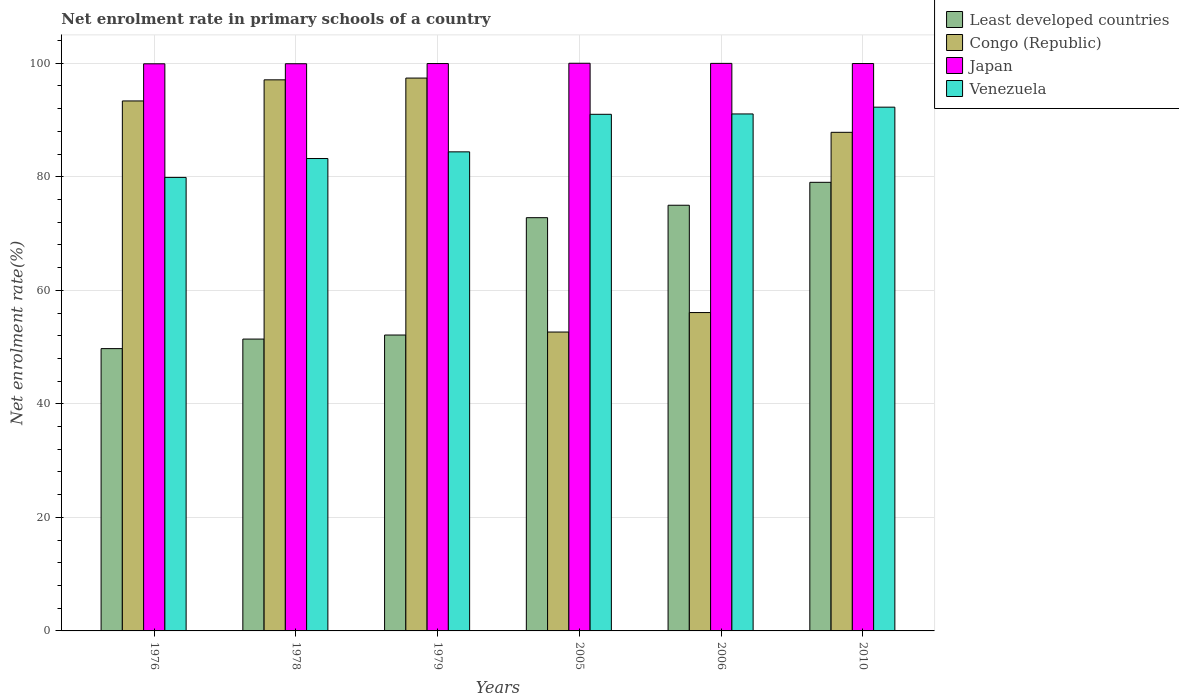How many groups of bars are there?
Provide a succinct answer. 6. Are the number of bars per tick equal to the number of legend labels?
Your response must be concise. Yes. In how many cases, is the number of bars for a given year not equal to the number of legend labels?
Provide a succinct answer. 0. What is the net enrolment rate in primary schools in Least developed countries in 2005?
Your response must be concise. 72.8. Across all years, what is the maximum net enrolment rate in primary schools in Venezuela?
Offer a terse response. 92.26. Across all years, what is the minimum net enrolment rate in primary schools in Congo (Republic)?
Offer a terse response. 52.65. In which year was the net enrolment rate in primary schools in Congo (Republic) maximum?
Your answer should be very brief. 1979. In which year was the net enrolment rate in primary schools in Least developed countries minimum?
Your answer should be compact. 1976. What is the total net enrolment rate in primary schools in Venezuela in the graph?
Your response must be concise. 521.84. What is the difference between the net enrolment rate in primary schools in Japan in 1976 and that in 1978?
Your answer should be compact. -0.01. What is the difference between the net enrolment rate in primary schools in Japan in 2010 and the net enrolment rate in primary schools in Venezuela in 1976?
Provide a succinct answer. 20.06. What is the average net enrolment rate in primary schools in Least developed countries per year?
Keep it short and to the point. 63.35. In the year 1978, what is the difference between the net enrolment rate in primary schools in Congo (Republic) and net enrolment rate in primary schools in Japan?
Make the answer very short. -2.83. What is the ratio of the net enrolment rate in primary schools in Least developed countries in 1978 to that in 2010?
Make the answer very short. 0.65. Is the net enrolment rate in primary schools in Congo (Republic) in 1978 less than that in 1979?
Give a very brief answer. Yes. What is the difference between the highest and the second highest net enrolment rate in primary schools in Japan?
Your answer should be very brief. 0.02. What is the difference between the highest and the lowest net enrolment rate in primary schools in Venezuela?
Keep it short and to the point. 12.37. Is the sum of the net enrolment rate in primary schools in Congo (Republic) in 1976 and 2005 greater than the maximum net enrolment rate in primary schools in Japan across all years?
Your response must be concise. Yes. Is it the case that in every year, the sum of the net enrolment rate in primary schools in Least developed countries and net enrolment rate in primary schools in Congo (Republic) is greater than the sum of net enrolment rate in primary schools in Japan and net enrolment rate in primary schools in Venezuela?
Give a very brief answer. No. What does the 3rd bar from the right in 2010 represents?
Your response must be concise. Congo (Republic). Are all the bars in the graph horizontal?
Provide a succinct answer. No. Are the values on the major ticks of Y-axis written in scientific E-notation?
Ensure brevity in your answer.  No. Where does the legend appear in the graph?
Your answer should be compact. Top right. How many legend labels are there?
Ensure brevity in your answer.  4. What is the title of the graph?
Keep it short and to the point. Net enrolment rate in primary schools of a country. Does "Central Europe" appear as one of the legend labels in the graph?
Provide a succinct answer. No. What is the label or title of the Y-axis?
Your answer should be very brief. Net enrolment rate(%). What is the Net enrolment rate(%) of Least developed countries in 1976?
Keep it short and to the point. 49.73. What is the Net enrolment rate(%) in Congo (Republic) in 1976?
Offer a very short reply. 93.36. What is the Net enrolment rate(%) of Japan in 1976?
Keep it short and to the point. 99.9. What is the Net enrolment rate(%) of Venezuela in 1976?
Ensure brevity in your answer.  79.89. What is the Net enrolment rate(%) of Least developed countries in 1978?
Ensure brevity in your answer.  51.41. What is the Net enrolment rate(%) of Congo (Republic) in 1978?
Provide a short and direct response. 97.08. What is the Net enrolment rate(%) of Japan in 1978?
Your response must be concise. 99.91. What is the Net enrolment rate(%) in Venezuela in 1978?
Provide a succinct answer. 83.22. What is the Net enrolment rate(%) in Least developed countries in 1979?
Your answer should be compact. 52.12. What is the Net enrolment rate(%) in Congo (Republic) in 1979?
Offer a very short reply. 97.39. What is the Net enrolment rate(%) of Japan in 1979?
Ensure brevity in your answer.  99.95. What is the Net enrolment rate(%) of Venezuela in 1979?
Provide a short and direct response. 84.39. What is the Net enrolment rate(%) in Least developed countries in 2005?
Keep it short and to the point. 72.8. What is the Net enrolment rate(%) in Congo (Republic) in 2005?
Ensure brevity in your answer.  52.65. What is the Net enrolment rate(%) of Japan in 2005?
Keep it short and to the point. 100. What is the Net enrolment rate(%) of Venezuela in 2005?
Provide a short and direct response. 91.01. What is the Net enrolment rate(%) in Least developed countries in 2006?
Keep it short and to the point. 74.99. What is the Net enrolment rate(%) of Congo (Republic) in 2006?
Provide a succinct answer. 56.08. What is the Net enrolment rate(%) in Japan in 2006?
Keep it short and to the point. 99.98. What is the Net enrolment rate(%) in Venezuela in 2006?
Make the answer very short. 91.07. What is the Net enrolment rate(%) in Least developed countries in 2010?
Give a very brief answer. 79.03. What is the Net enrolment rate(%) of Congo (Republic) in 2010?
Provide a short and direct response. 87.83. What is the Net enrolment rate(%) of Japan in 2010?
Keep it short and to the point. 99.95. What is the Net enrolment rate(%) in Venezuela in 2010?
Give a very brief answer. 92.26. Across all years, what is the maximum Net enrolment rate(%) in Least developed countries?
Ensure brevity in your answer.  79.03. Across all years, what is the maximum Net enrolment rate(%) in Congo (Republic)?
Give a very brief answer. 97.39. Across all years, what is the maximum Net enrolment rate(%) in Japan?
Provide a succinct answer. 100. Across all years, what is the maximum Net enrolment rate(%) in Venezuela?
Provide a short and direct response. 92.26. Across all years, what is the minimum Net enrolment rate(%) of Least developed countries?
Your answer should be very brief. 49.73. Across all years, what is the minimum Net enrolment rate(%) of Congo (Republic)?
Offer a terse response. 52.65. Across all years, what is the minimum Net enrolment rate(%) in Japan?
Provide a short and direct response. 99.9. Across all years, what is the minimum Net enrolment rate(%) of Venezuela?
Ensure brevity in your answer.  79.89. What is the total Net enrolment rate(%) of Least developed countries in the graph?
Provide a succinct answer. 380.07. What is the total Net enrolment rate(%) of Congo (Republic) in the graph?
Keep it short and to the point. 484.4. What is the total Net enrolment rate(%) in Japan in the graph?
Offer a terse response. 599.69. What is the total Net enrolment rate(%) in Venezuela in the graph?
Offer a very short reply. 521.84. What is the difference between the Net enrolment rate(%) of Least developed countries in 1976 and that in 1978?
Your answer should be compact. -1.68. What is the difference between the Net enrolment rate(%) in Congo (Republic) in 1976 and that in 1978?
Your answer should be compact. -3.72. What is the difference between the Net enrolment rate(%) in Japan in 1976 and that in 1978?
Your answer should be very brief. -0.01. What is the difference between the Net enrolment rate(%) in Venezuela in 1976 and that in 1978?
Ensure brevity in your answer.  -3.33. What is the difference between the Net enrolment rate(%) in Least developed countries in 1976 and that in 1979?
Give a very brief answer. -2.39. What is the difference between the Net enrolment rate(%) in Congo (Republic) in 1976 and that in 1979?
Keep it short and to the point. -4.03. What is the difference between the Net enrolment rate(%) of Japan in 1976 and that in 1979?
Keep it short and to the point. -0.04. What is the difference between the Net enrolment rate(%) in Venezuela in 1976 and that in 1979?
Make the answer very short. -4.5. What is the difference between the Net enrolment rate(%) of Least developed countries in 1976 and that in 2005?
Your response must be concise. -23.07. What is the difference between the Net enrolment rate(%) in Congo (Republic) in 1976 and that in 2005?
Your answer should be very brief. 40.71. What is the difference between the Net enrolment rate(%) in Japan in 1976 and that in 2005?
Your answer should be very brief. -0.09. What is the difference between the Net enrolment rate(%) of Venezuela in 1976 and that in 2005?
Your answer should be very brief. -11.12. What is the difference between the Net enrolment rate(%) in Least developed countries in 1976 and that in 2006?
Give a very brief answer. -25.26. What is the difference between the Net enrolment rate(%) in Congo (Republic) in 1976 and that in 2006?
Give a very brief answer. 37.28. What is the difference between the Net enrolment rate(%) of Japan in 1976 and that in 2006?
Provide a succinct answer. -0.07. What is the difference between the Net enrolment rate(%) in Venezuela in 1976 and that in 2006?
Ensure brevity in your answer.  -11.18. What is the difference between the Net enrolment rate(%) in Least developed countries in 1976 and that in 2010?
Provide a succinct answer. -29.3. What is the difference between the Net enrolment rate(%) in Congo (Republic) in 1976 and that in 2010?
Your answer should be very brief. 5.53. What is the difference between the Net enrolment rate(%) in Japan in 1976 and that in 2010?
Offer a terse response. -0.05. What is the difference between the Net enrolment rate(%) in Venezuela in 1976 and that in 2010?
Keep it short and to the point. -12.37. What is the difference between the Net enrolment rate(%) of Least developed countries in 1978 and that in 1979?
Provide a short and direct response. -0.71. What is the difference between the Net enrolment rate(%) of Congo (Republic) in 1978 and that in 1979?
Keep it short and to the point. -0.31. What is the difference between the Net enrolment rate(%) in Japan in 1978 and that in 1979?
Keep it short and to the point. -0.03. What is the difference between the Net enrolment rate(%) in Venezuela in 1978 and that in 1979?
Ensure brevity in your answer.  -1.18. What is the difference between the Net enrolment rate(%) in Least developed countries in 1978 and that in 2005?
Offer a terse response. -21.39. What is the difference between the Net enrolment rate(%) of Congo (Republic) in 1978 and that in 2005?
Provide a short and direct response. 44.43. What is the difference between the Net enrolment rate(%) of Japan in 1978 and that in 2005?
Keep it short and to the point. -0.09. What is the difference between the Net enrolment rate(%) of Venezuela in 1978 and that in 2005?
Give a very brief answer. -7.79. What is the difference between the Net enrolment rate(%) of Least developed countries in 1978 and that in 2006?
Make the answer very short. -23.58. What is the difference between the Net enrolment rate(%) of Congo (Republic) in 1978 and that in 2006?
Your answer should be compact. 40.99. What is the difference between the Net enrolment rate(%) in Japan in 1978 and that in 2006?
Your response must be concise. -0.06. What is the difference between the Net enrolment rate(%) of Venezuela in 1978 and that in 2006?
Your answer should be compact. -7.85. What is the difference between the Net enrolment rate(%) in Least developed countries in 1978 and that in 2010?
Make the answer very short. -27.61. What is the difference between the Net enrolment rate(%) in Congo (Republic) in 1978 and that in 2010?
Your response must be concise. 9.25. What is the difference between the Net enrolment rate(%) of Japan in 1978 and that in 2010?
Keep it short and to the point. -0.04. What is the difference between the Net enrolment rate(%) of Venezuela in 1978 and that in 2010?
Your answer should be very brief. -9.05. What is the difference between the Net enrolment rate(%) of Least developed countries in 1979 and that in 2005?
Ensure brevity in your answer.  -20.67. What is the difference between the Net enrolment rate(%) in Congo (Republic) in 1979 and that in 2005?
Offer a very short reply. 44.74. What is the difference between the Net enrolment rate(%) in Japan in 1979 and that in 2005?
Your response must be concise. -0.05. What is the difference between the Net enrolment rate(%) of Venezuela in 1979 and that in 2005?
Your answer should be very brief. -6.61. What is the difference between the Net enrolment rate(%) of Least developed countries in 1979 and that in 2006?
Your answer should be compact. -22.86. What is the difference between the Net enrolment rate(%) of Congo (Republic) in 1979 and that in 2006?
Ensure brevity in your answer.  41.31. What is the difference between the Net enrolment rate(%) in Japan in 1979 and that in 2006?
Provide a succinct answer. -0.03. What is the difference between the Net enrolment rate(%) in Venezuela in 1979 and that in 2006?
Ensure brevity in your answer.  -6.68. What is the difference between the Net enrolment rate(%) of Least developed countries in 1979 and that in 2010?
Your response must be concise. -26.9. What is the difference between the Net enrolment rate(%) in Congo (Republic) in 1979 and that in 2010?
Provide a succinct answer. 9.56. What is the difference between the Net enrolment rate(%) in Japan in 1979 and that in 2010?
Provide a short and direct response. -0. What is the difference between the Net enrolment rate(%) in Venezuela in 1979 and that in 2010?
Your answer should be very brief. -7.87. What is the difference between the Net enrolment rate(%) in Least developed countries in 2005 and that in 2006?
Make the answer very short. -2.19. What is the difference between the Net enrolment rate(%) of Congo (Republic) in 2005 and that in 2006?
Keep it short and to the point. -3.43. What is the difference between the Net enrolment rate(%) of Japan in 2005 and that in 2006?
Ensure brevity in your answer.  0.02. What is the difference between the Net enrolment rate(%) of Venezuela in 2005 and that in 2006?
Offer a very short reply. -0.06. What is the difference between the Net enrolment rate(%) of Least developed countries in 2005 and that in 2010?
Offer a very short reply. -6.23. What is the difference between the Net enrolment rate(%) of Congo (Republic) in 2005 and that in 2010?
Keep it short and to the point. -35.18. What is the difference between the Net enrolment rate(%) in Japan in 2005 and that in 2010?
Make the answer very short. 0.05. What is the difference between the Net enrolment rate(%) in Venezuela in 2005 and that in 2010?
Keep it short and to the point. -1.26. What is the difference between the Net enrolment rate(%) of Least developed countries in 2006 and that in 2010?
Provide a succinct answer. -4.04. What is the difference between the Net enrolment rate(%) in Congo (Republic) in 2006 and that in 2010?
Keep it short and to the point. -31.75. What is the difference between the Net enrolment rate(%) of Japan in 2006 and that in 2010?
Keep it short and to the point. 0.03. What is the difference between the Net enrolment rate(%) of Venezuela in 2006 and that in 2010?
Your answer should be compact. -1.19. What is the difference between the Net enrolment rate(%) of Least developed countries in 1976 and the Net enrolment rate(%) of Congo (Republic) in 1978?
Provide a succinct answer. -47.35. What is the difference between the Net enrolment rate(%) in Least developed countries in 1976 and the Net enrolment rate(%) in Japan in 1978?
Ensure brevity in your answer.  -50.18. What is the difference between the Net enrolment rate(%) of Least developed countries in 1976 and the Net enrolment rate(%) of Venezuela in 1978?
Keep it short and to the point. -33.49. What is the difference between the Net enrolment rate(%) of Congo (Republic) in 1976 and the Net enrolment rate(%) of Japan in 1978?
Ensure brevity in your answer.  -6.55. What is the difference between the Net enrolment rate(%) of Congo (Republic) in 1976 and the Net enrolment rate(%) of Venezuela in 1978?
Your response must be concise. 10.14. What is the difference between the Net enrolment rate(%) of Japan in 1976 and the Net enrolment rate(%) of Venezuela in 1978?
Offer a very short reply. 16.69. What is the difference between the Net enrolment rate(%) in Least developed countries in 1976 and the Net enrolment rate(%) in Congo (Republic) in 1979?
Ensure brevity in your answer.  -47.66. What is the difference between the Net enrolment rate(%) in Least developed countries in 1976 and the Net enrolment rate(%) in Japan in 1979?
Offer a terse response. -50.22. What is the difference between the Net enrolment rate(%) in Least developed countries in 1976 and the Net enrolment rate(%) in Venezuela in 1979?
Offer a very short reply. -34.66. What is the difference between the Net enrolment rate(%) in Congo (Republic) in 1976 and the Net enrolment rate(%) in Japan in 1979?
Give a very brief answer. -6.59. What is the difference between the Net enrolment rate(%) of Congo (Republic) in 1976 and the Net enrolment rate(%) of Venezuela in 1979?
Offer a very short reply. 8.97. What is the difference between the Net enrolment rate(%) of Japan in 1976 and the Net enrolment rate(%) of Venezuela in 1979?
Ensure brevity in your answer.  15.51. What is the difference between the Net enrolment rate(%) in Least developed countries in 1976 and the Net enrolment rate(%) in Congo (Republic) in 2005?
Offer a terse response. -2.92. What is the difference between the Net enrolment rate(%) of Least developed countries in 1976 and the Net enrolment rate(%) of Japan in 2005?
Make the answer very short. -50.27. What is the difference between the Net enrolment rate(%) in Least developed countries in 1976 and the Net enrolment rate(%) in Venezuela in 2005?
Keep it short and to the point. -41.28. What is the difference between the Net enrolment rate(%) of Congo (Republic) in 1976 and the Net enrolment rate(%) of Japan in 2005?
Provide a succinct answer. -6.64. What is the difference between the Net enrolment rate(%) of Congo (Republic) in 1976 and the Net enrolment rate(%) of Venezuela in 2005?
Keep it short and to the point. 2.35. What is the difference between the Net enrolment rate(%) of Japan in 1976 and the Net enrolment rate(%) of Venezuela in 2005?
Make the answer very short. 8.9. What is the difference between the Net enrolment rate(%) in Least developed countries in 1976 and the Net enrolment rate(%) in Congo (Republic) in 2006?
Provide a succinct answer. -6.35. What is the difference between the Net enrolment rate(%) of Least developed countries in 1976 and the Net enrolment rate(%) of Japan in 2006?
Offer a terse response. -50.25. What is the difference between the Net enrolment rate(%) in Least developed countries in 1976 and the Net enrolment rate(%) in Venezuela in 2006?
Provide a succinct answer. -41.34. What is the difference between the Net enrolment rate(%) in Congo (Republic) in 1976 and the Net enrolment rate(%) in Japan in 2006?
Your answer should be very brief. -6.62. What is the difference between the Net enrolment rate(%) in Congo (Republic) in 1976 and the Net enrolment rate(%) in Venezuela in 2006?
Ensure brevity in your answer.  2.29. What is the difference between the Net enrolment rate(%) of Japan in 1976 and the Net enrolment rate(%) of Venezuela in 2006?
Give a very brief answer. 8.83. What is the difference between the Net enrolment rate(%) in Least developed countries in 1976 and the Net enrolment rate(%) in Congo (Republic) in 2010?
Your answer should be very brief. -38.1. What is the difference between the Net enrolment rate(%) in Least developed countries in 1976 and the Net enrolment rate(%) in Japan in 2010?
Offer a terse response. -50.22. What is the difference between the Net enrolment rate(%) of Least developed countries in 1976 and the Net enrolment rate(%) of Venezuela in 2010?
Your answer should be compact. -42.53. What is the difference between the Net enrolment rate(%) of Congo (Republic) in 1976 and the Net enrolment rate(%) of Japan in 2010?
Ensure brevity in your answer.  -6.59. What is the difference between the Net enrolment rate(%) in Congo (Republic) in 1976 and the Net enrolment rate(%) in Venezuela in 2010?
Keep it short and to the point. 1.1. What is the difference between the Net enrolment rate(%) in Japan in 1976 and the Net enrolment rate(%) in Venezuela in 2010?
Ensure brevity in your answer.  7.64. What is the difference between the Net enrolment rate(%) of Least developed countries in 1978 and the Net enrolment rate(%) of Congo (Republic) in 1979?
Your answer should be very brief. -45.98. What is the difference between the Net enrolment rate(%) in Least developed countries in 1978 and the Net enrolment rate(%) in Japan in 1979?
Your answer should be compact. -48.54. What is the difference between the Net enrolment rate(%) in Least developed countries in 1978 and the Net enrolment rate(%) in Venezuela in 1979?
Offer a terse response. -32.98. What is the difference between the Net enrolment rate(%) in Congo (Republic) in 1978 and the Net enrolment rate(%) in Japan in 1979?
Your answer should be compact. -2.87. What is the difference between the Net enrolment rate(%) in Congo (Republic) in 1978 and the Net enrolment rate(%) in Venezuela in 1979?
Provide a succinct answer. 12.69. What is the difference between the Net enrolment rate(%) of Japan in 1978 and the Net enrolment rate(%) of Venezuela in 1979?
Provide a short and direct response. 15.52. What is the difference between the Net enrolment rate(%) in Least developed countries in 1978 and the Net enrolment rate(%) in Congo (Republic) in 2005?
Give a very brief answer. -1.24. What is the difference between the Net enrolment rate(%) of Least developed countries in 1978 and the Net enrolment rate(%) of Japan in 2005?
Ensure brevity in your answer.  -48.59. What is the difference between the Net enrolment rate(%) of Least developed countries in 1978 and the Net enrolment rate(%) of Venezuela in 2005?
Ensure brevity in your answer.  -39.6. What is the difference between the Net enrolment rate(%) of Congo (Republic) in 1978 and the Net enrolment rate(%) of Japan in 2005?
Your response must be concise. -2.92. What is the difference between the Net enrolment rate(%) in Congo (Republic) in 1978 and the Net enrolment rate(%) in Venezuela in 2005?
Keep it short and to the point. 6.07. What is the difference between the Net enrolment rate(%) of Japan in 1978 and the Net enrolment rate(%) of Venezuela in 2005?
Your response must be concise. 8.91. What is the difference between the Net enrolment rate(%) of Least developed countries in 1978 and the Net enrolment rate(%) of Congo (Republic) in 2006?
Offer a terse response. -4.67. What is the difference between the Net enrolment rate(%) of Least developed countries in 1978 and the Net enrolment rate(%) of Japan in 2006?
Your answer should be very brief. -48.57. What is the difference between the Net enrolment rate(%) in Least developed countries in 1978 and the Net enrolment rate(%) in Venezuela in 2006?
Your response must be concise. -39.66. What is the difference between the Net enrolment rate(%) of Congo (Republic) in 1978 and the Net enrolment rate(%) of Japan in 2006?
Keep it short and to the point. -2.9. What is the difference between the Net enrolment rate(%) in Congo (Republic) in 1978 and the Net enrolment rate(%) in Venezuela in 2006?
Provide a short and direct response. 6.01. What is the difference between the Net enrolment rate(%) of Japan in 1978 and the Net enrolment rate(%) of Venezuela in 2006?
Offer a terse response. 8.84. What is the difference between the Net enrolment rate(%) in Least developed countries in 1978 and the Net enrolment rate(%) in Congo (Republic) in 2010?
Ensure brevity in your answer.  -36.42. What is the difference between the Net enrolment rate(%) of Least developed countries in 1978 and the Net enrolment rate(%) of Japan in 2010?
Give a very brief answer. -48.54. What is the difference between the Net enrolment rate(%) of Least developed countries in 1978 and the Net enrolment rate(%) of Venezuela in 2010?
Your response must be concise. -40.85. What is the difference between the Net enrolment rate(%) of Congo (Republic) in 1978 and the Net enrolment rate(%) of Japan in 2010?
Give a very brief answer. -2.87. What is the difference between the Net enrolment rate(%) in Congo (Republic) in 1978 and the Net enrolment rate(%) in Venezuela in 2010?
Ensure brevity in your answer.  4.81. What is the difference between the Net enrolment rate(%) in Japan in 1978 and the Net enrolment rate(%) in Venezuela in 2010?
Your answer should be compact. 7.65. What is the difference between the Net enrolment rate(%) in Least developed countries in 1979 and the Net enrolment rate(%) in Congo (Republic) in 2005?
Offer a terse response. -0.53. What is the difference between the Net enrolment rate(%) in Least developed countries in 1979 and the Net enrolment rate(%) in Japan in 2005?
Your answer should be very brief. -47.87. What is the difference between the Net enrolment rate(%) in Least developed countries in 1979 and the Net enrolment rate(%) in Venezuela in 2005?
Give a very brief answer. -38.88. What is the difference between the Net enrolment rate(%) in Congo (Republic) in 1979 and the Net enrolment rate(%) in Japan in 2005?
Make the answer very short. -2.61. What is the difference between the Net enrolment rate(%) of Congo (Republic) in 1979 and the Net enrolment rate(%) of Venezuela in 2005?
Offer a terse response. 6.38. What is the difference between the Net enrolment rate(%) in Japan in 1979 and the Net enrolment rate(%) in Venezuela in 2005?
Your answer should be compact. 8.94. What is the difference between the Net enrolment rate(%) in Least developed countries in 1979 and the Net enrolment rate(%) in Congo (Republic) in 2006?
Provide a succinct answer. -3.96. What is the difference between the Net enrolment rate(%) of Least developed countries in 1979 and the Net enrolment rate(%) of Japan in 2006?
Make the answer very short. -47.85. What is the difference between the Net enrolment rate(%) in Least developed countries in 1979 and the Net enrolment rate(%) in Venezuela in 2006?
Your answer should be very brief. -38.94. What is the difference between the Net enrolment rate(%) of Congo (Republic) in 1979 and the Net enrolment rate(%) of Japan in 2006?
Your answer should be very brief. -2.59. What is the difference between the Net enrolment rate(%) of Congo (Republic) in 1979 and the Net enrolment rate(%) of Venezuela in 2006?
Your response must be concise. 6.32. What is the difference between the Net enrolment rate(%) of Japan in 1979 and the Net enrolment rate(%) of Venezuela in 2006?
Ensure brevity in your answer.  8.88. What is the difference between the Net enrolment rate(%) in Least developed countries in 1979 and the Net enrolment rate(%) in Congo (Republic) in 2010?
Make the answer very short. -35.71. What is the difference between the Net enrolment rate(%) of Least developed countries in 1979 and the Net enrolment rate(%) of Japan in 2010?
Provide a short and direct response. -47.83. What is the difference between the Net enrolment rate(%) of Least developed countries in 1979 and the Net enrolment rate(%) of Venezuela in 2010?
Keep it short and to the point. -40.14. What is the difference between the Net enrolment rate(%) in Congo (Republic) in 1979 and the Net enrolment rate(%) in Japan in 2010?
Provide a short and direct response. -2.56. What is the difference between the Net enrolment rate(%) of Congo (Republic) in 1979 and the Net enrolment rate(%) of Venezuela in 2010?
Your answer should be very brief. 5.13. What is the difference between the Net enrolment rate(%) in Japan in 1979 and the Net enrolment rate(%) in Venezuela in 2010?
Offer a terse response. 7.68. What is the difference between the Net enrolment rate(%) of Least developed countries in 2005 and the Net enrolment rate(%) of Congo (Republic) in 2006?
Offer a terse response. 16.71. What is the difference between the Net enrolment rate(%) in Least developed countries in 2005 and the Net enrolment rate(%) in Japan in 2006?
Offer a very short reply. -27.18. What is the difference between the Net enrolment rate(%) of Least developed countries in 2005 and the Net enrolment rate(%) of Venezuela in 2006?
Your response must be concise. -18.27. What is the difference between the Net enrolment rate(%) of Congo (Republic) in 2005 and the Net enrolment rate(%) of Japan in 2006?
Your answer should be very brief. -47.33. What is the difference between the Net enrolment rate(%) of Congo (Republic) in 2005 and the Net enrolment rate(%) of Venezuela in 2006?
Offer a terse response. -38.42. What is the difference between the Net enrolment rate(%) of Japan in 2005 and the Net enrolment rate(%) of Venezuela in 2006?
Make the answer very short. 8.93. What is the difference between the Net enrolment rate(%) in Least developed countries in 2005 and the Net enrolment rate(%) in Congo (Republic) in 2010?
Provide a short and direct response. -15.04. What is the difference between the Net enrolment rate(%) in Least developed countries in 2005 and the Net enrolment rate(%) in Japan in 2010?
Your answer should be very brief. -27.15. What is the difference between the Net enrolment rate(%) in Least developed countries in 2005 and the Net enrolment rate(%) in Venezuela in 2010?
Your answer should be compact. -19.47. What is the difference between the Net enrolment rate(%) of Congo (Republic) in 2005 and the Net enrolment rate(%) of Japan in 2010?
Make the answer very short. -47.3. What is the difference between the Net enrolment rate(%) of Congo (Republic) in 2005 and the Net enrolment rate(%) of Venezuela in 2010?
Provide a short and direct response. -39.61. What is the difference between the Net enrolment rate(%) of Japan in 2005 and the Net enrolment rate(%) of Venezuela in 2010?
Your answer should be very brief. 7.74. What is the difference between the Net enrolment rate(%) in Least developed countries in 2006 and the Net enrolment rate(%) in Congo (Republic) in 2010?
Provide a succinct answer. -12.84. What is the difference between the Net enrolment rate(%) in Least developed countries in 2006 and the Net enrolment rate(%) in Japan in 2010?
Ensure brevity in your answer.  -24.96. What is the difference between the Net enrolment rate(%) of Least developed countries in 2006 and the Net enrolment rate(%) of Venezuela in 2010?
Make the answer very short. -17.28. What is the difference between the Net enrolment rate(%) of Congo (Republic) in 2006 and the Net enrolment rate(%) of Japan in 2010?
Make the answer very short. -43.87. What is the difference between the Net enrolment rate(%) in Congo (Republic) in 2006 and the Net enrolment rate(%) in Venezuela in 2010?
Ensure brevity in your answer.  -36.18. What is the difference between the Net enrolment rate(%) of Japan in 2006 and the Net enrolment rate(%) of Venezuela in 2010?
Your response must be concise. 7.71. What is the average Net enrolment rate(%) of Least developed countries per year?
Keep it short and to the point. 63.35. What is the average Net enrolment rate(%) in Congo (Republic) per year?
Ensure brevity in your answer.  80.73. What is the average Net enrolment rate(%) of Japan per year?
Offer a terse response. 99.95. What is the average Net enrolment rate(%) of Venezuela per year?
Your answer should be very brief. 86.97. In the year 1976, what is the difference between the Net enrolment rate(%) of Least developed countries and Net enrolment rate(%) of Congo (Republic)?
Your answer should be very brief. -43.63. In the year 1976, what is the difference between the Net enrolment rate(%) of Least developed countries and Net enrolment rate(%) of Japan?
Your answer should be compact. -50.17. In the year 1976, what is the difference between the Net enrolment rate(%) of Least developed countries and Net enrolment rate(%) of Venezuela?
Your response must be concise. -30.16. In the year 1976, what is the difference between the Net enrolment rate(%) of Congo (Republic) and Net enrolment rate(%) of Japan?
Make the answer very short. -6.54. In the year 1976, what is the difference between the Net enrolment rate(%) of Congo (Republic) and Net enrolment rate(%) of Venezuela?
Ensure brevity in your answer.  13.47. In the year 1976, what is the difference between the Net enrolment rate(%) in Japan and Net enrolment rate(%) in Venezuela?
Provide a short and direct response. 20.01. In the year 1978, what is the difference between the Net enrolment rate(%) of Least developed countries and Net enrolment rate(%) of Congo (Republic)?
Give a very brief answer. -45.67. In the year 1978, what is the difference between the Net enrolment rate(%) of Least developed countries and Net enrolment rate(%) of Japan?
Give a very brief answer. -48.5. In the year 1978, what is the difference between the Net enrolment rate(%) of Least developed countries and Net enrolment rate(%) of Venezuela?
Your answer should be compact. -31.81. In the year 1978, what is the difference between the Net enrolment rate(%) of Congo (Republic) and Net enrolment rate(%) of Japan?
Provide a short and direct response. -2.83. In the year 1978, what is the difference between the Net enrolment rate(%) of Congo (Republic) and Net enrolment rate(%) of Venezuela?
Give a very brief answer. 13.86. In the year 1978, what is the difference between the Net enrolment rate(%) in Japan and Net enrolment rate(%) in Venezuela?
Ensure brevity in your answer.  16.7. In the year 1979, what is the difference between the Net enrolment rate(%) of Least developed countries and Net enrolment rate(%) of Congo (Republic)?
Ensure brevity in your answer.  -45.27. In the year 1979, what is the difference between the Net enrolment rate(%) in Least developed countries and Net enrolment rate(%) in Japan?
Provide a short and direct response. -47.82. In the year 1979, what is the difference between the Net enrolment rate(%) of Least developed countries and Net enrolment rate(%) of Venezuela?
Give a very brief answer. -32.27. In the year 1979, what is the difference between the Net enrolment rate(%) in Congo (Republic) and Net enrolment rate(%) in Japan?
Make the answer very short. -2.56. In the year 1979, what is the difference between the Net enrolment rate(%) in Congo (Republic) and Net enrolment rate(%) in Venezuela?
Provide a short and direct response. 13. In the year 1979, what is the difference between the Net enrolment rate(%) of Japan and Net enrolment rate(%) of Venezuela?
Give a very brief answer. 15.55. In the year 2005, what is the difference between the Net enrolment rate(%) in Least developed countries and Net enrolment rate(%) in Congo (Republic)?
Offer a terse response. 20.15. In the year 2005, what is the difference between the Net enrolment rate(%) of Least developed countries and Net enrolment rate(%) of Japan?
Make the answer very short. -27.2. In the year 2005, what is the difference between the Net enrolment rate(%) of Least developed countries and Net enrolment rate(%) of Venezuela?
Give a very brief answer. -18.21. In the year 2005, what is the difference between the Net enrolment rate(%) of Congo (Republic) and Net enrolment rate(%) of Japan?
Offer a terse response. -47.35. In the year 2005, what is the difference between the Net enrolment rate(%) in Congo (Republic) and Net enrolment rate(%) in Venezuela?
Provide a succinct answer. -38.36. In the year 2005, what is the difference between the Net enrolment rate(%) in Japan and Net enrolment rate(%) in Venezuela?
Keep it short and to the point. 8.99. In the year 2006, what is the difference between the Net enrolment rate(%) of Least developed countries and Net enrolment rate(%) of Congo (Republic)?
Your answer should be compact. 18.9. In the year 2006, what is the difference between the Net enrolment rate(%) of Least developed countries and Net enrolment rate(%) of Japan?
Keep it short and to the point. -24.99. In the year 2006, what is the difference between the Net enrolment rate(%) of Least developed countries and Net enrolment rate(%) of Venezuela?
Make the answer very short. -16.08. In the year 2006, what is the difference between the Net enrolment rate(%) in Congo (Republic) and Net enrolment rate(%) in Japan?
Provide a succinct answer. -43.89. In the year 2006, what is the difference between the Net enrolment rate(%) of Congo (Republic) and Net enrolment rate(%) of Venezuela?
Your response must be concise. -34.98. In the year 2006, what is the difference between the Net enrolment rate(%) of Japan and Net enrolment rate(%) of Venezuela?
Make the answer very short. 8.91. In the year 2010, what is the difference between the Net enrolment rate(%) of Least developed countries and Net enrolment rate(%) of Congo (Republic)?
Provide a succinct answer. -8.81. In the year 2010, what is the difference between the Net enrolment rate(%) of Least developed countries and Net enrolment rate(%) of Japan?
Your answer should be very brief. -20.92. In the year 2010, what is the difference between the Net enrolment rate(%) in Least developed countries and Net enrolment rate(%) in Venezuela?
Your response must be concise. -13.24. In the year 2010, what is the difference between the Net enrolment rate(%) of Congo (Republic) and Net enrolment rate(%) of Japan?
Offer a very short reply. -12.12. In the year 2010, what is the difference between the Net enrolment rate(%) of Congo (Republic) and Net enrolment rate(%) of Venezuela?
Offer a terse response. -4.43. In the year 2010, what is the difference between the Net enrolment rate(%) of Japan and Net enrolment rate(%) of Venezuela?
Make the answer very short. 7.69. What is the ratio of the Net enrolment rate(%) of Least developed countries in 1976 to that in 1978?
Offer a terse response. 0.97. What is the ratio of the Net enrolment rate(%) in Congo (Republic) in 1976 to that in 1978?
Provide a short and direct response. 0.96. What is the ratio of the Net enrolment rate(%) in Japan in 1976 to that in 1978?
Your answer should be very brief. 1. What is the ratio of the Net enrolment rate(%) of Venezuela in 1976 to that in 1978?
Offer a terse response. 0.96. What is the ratio of the Net enrolment rate(%) of Least developed countries in 1976 to that in 1979?
Make the answer very short. 0.95. What is the ratio of the Net enrolment rate(%) in Congo (Republic) in 1976 to that in 1979?
Provide a short and direct response. 0.96. What is the ratio of the Net enrolment rate(%) in Japan in 1976 to that in 1979?
Offer a very short reply. 1. What is the ratio of the Net enrolment rate(%) of Venezuela in 1976 to that in 1979?
Offer a very short reply. 0.95. What is the ratio of the Net enrolment rate(%) in Least developed countries in 1976 to that in 2005?
Ensure brevity in your answer.  0.68. What is the ratio of the Net enrolment rate(%) of Congo (Republic) in 1976 to that in 2005?
Ensure brevity in your answer.  1.77. What is the ratio of the Net enrolment rate(%) of Japan in 1976 to that in 2005?
Ensure brevity in your answer.  1. What is the ratio of the Net enrolment rate(%) in Venezuela in 1976 to that in 2005?
Ensure brevity in your answer.  0.88. What is the ratio of the Net enrolment rate(%) of Least developed countries in 1976 to that in 2006?
Provide a short and direct response. 0.66. What is the ratio of the Net enrolment rate(%) of Congo (Republic) in 1976 to that in 2006?
Provide a short and direct response. 1.66. What is the ratio of the Net enrolment rate(%) of Venezuela in 1976 to that in 2006?
Keep it short and to the point. 0.88. What is the ratio of the Net enrolment rate(%) of Least developed countries in 1976 to that in 2010?
Provide a short and direct response. 0.63. What is the ratio of the Net enrolment rate(%) of Congo (Republic) in 1976 to that in 2010?
Give a very brief answer. 1.06. What is the ratio of the Net enrolment rate(%) of Japan in 1976 to that in 2010?
Ensure brevity in your answer.  1. What is the ratio of the Net enrolment rate(%) in Venezuela in 1976 to that in 2010?
Give a very brief answer. 0.87. What is the ratio of the Net enrolment rate(%) in Least developed countries in 1978 to that in 1979?
Provide a short and direct response. 0.99. What is the ratio of the Net enrolment rate(%) of Congo (Republic) in 1978 to that in 1979?
Your answer should be very brief. 1. What is the ratio of the Net enrolment rate(%) of Japan in 1978 to that in 1979?
Give a very brief answer. 1. What is the ratio of the Net enrolment rate(%) in Venezuela in 1978 to that in 1979?
Your answer should be compact. 0.99. What is the ratio of the Net enrolment rate(%) of Least developed countries in 1978 to that in 2005?
Your response must be concise. 0.71. What is the ratio of the Net enrolment rate(%) in Congo (Republic) in 1978 to that in 2005?
Provide a succinct answer. 1.84. What is the ratio of the Net enrolment rate(%) of Japan in 1978 to that in 2005?
Provide a succinct answer. 1. What is the ratio of the Net enrolment rate(%) of Venezuela in 1978 to that in 2005?
Provide a succinct answer. 0.91. What is the ratio of the Net enrolment rate(%) of Least developed countries in 1978 to that in 2006?
Offer a very short reply. 0.69. What is the ratio of the Net enrolment rate(%) of Congo (Republic) in 1978 to that in 2006?
Provide a succinct answer. 1.73. What is the ratio of the Net enrolment rate(%) in Venezuela in 1978 to that in 2006?
Your answer should be very brief. 0.91. What is the ratio of the Net enrolment rate(%) in Least developed countries in 1978 to that in 2010?
Provide a short and direct response. 0.65. What is the ratio of the Net enrolment rate(%) of Congo (Republic) in 1978 to that in 2010?
Your response must be concise. 1.11. What is the ratio of the Net enrolment rate(%) in Venezuela in 1978 to that in 2010?
Offer a very short reply. 0.9. What is the ratio of the Net enrolment rate(%) of Least developed countries in 1979 to that in 2005?
Offer a very short reply. 0.72. What is the ratio of the Net enrolment rate(%) of Congo (Republic) in 1979 to that in 2005?
Make the answer very short. 1.85. What is the ratio of the Net enrolment rate(%) in Venezuela in 1979 to that in 2005?
Make the answer very short. 0.93. What is the ratio of the Net enrolment rate(%) of Least developed countries in 1979 to that in 2006?
Keep it short and to the point. 0.7. What is the ratio of the Net enrolment rate(%) in Congo (Republic) in 1979 to that in 2006?
Your answer should be very brief. 1.74. What is the ratio of the Net enrolment rate(%) in Japan in 1979 to that in 2006?
Provide a short and direct response. 1. What is the ratio of the Net enrolment rate(%) of Venezuela in 1979 to that in 2006?
Provide a short and direct response. 0.93. What is the ratio of the Net enrolment rate(%) of Least developed countries in 1979 to that in 2010?
Give a very brief answer. 0.66. What is the ratio of the Net enrolment rate(%) of Congo (Republic) in 1979 to that in 2010?
Offer a terse response. 1.11. What is the ratio of the Net enrolment rate(%) of Venezuela in 1979 to that in 2010?
Keep it short and to the point. 0.91. What is the ratio of the Net enrolment rate(%) of Least developed countries in 2005 to that in 2006?
Provide a succinct answer. 0.97. What is the ratio of the Net enrolment rate(%) of Congo (Republic) in 2005 to that in 2006?
Give a very brief answer. 0.94. What is the ratio of the Net enrolment rate(%) of Japan in 2005 to that in 2006?
Keep it short and to the point. 1. What is the ratio of the Net enrolment rate(%) of Least developed countries in 2005 to that in 2010?
Offer a terse response. 0.92. What is the ratio of the Net enrolment rate(%) in Congo (Republic) in 2005 to that in 2010?
Give a very brief answer. 0.6. What is the ratio of the Net enrolment rate(%) of Japan in 2005 to that in 2010?
Your answer should be compact. 1. What is the ratio of the Net enrolment rate(%) of Venezuela in 2005 to that in 2010?
Give a very brief answer. 0.99. What is the ratio of the Net enrolment rate(%) in Least developed countries in 2006 to that in 2010?
Provide a short and direct response. 0.95. What is the ratio of the Net enrolment rate(%) of Congo (Republic) in 2006 to that in 2010?
Provide a succinct answer. 0.64. What is the ratio of the Net enrolment rate(%) in Venezuela in 2006 to that in 2010?
Make the answer very short. 0.99. What is the difference between the highest and the second highest Net enrolment rate(%) in Least developed countries?
Provide a succinct answer. 4.04. What is the difference between the highest and the second highest Net enrolment rate(%) in Congo (Republic)?
Your answer should be very brief. 0.31. What is the difference between the highest and the second highest Net enrolment rate(%) in Japan?
Provide a succinct answer. 0.02. What is the difference between the highest and the second highest Net enrolment rate(%) in Venezuela?
Offer a very short reply. 1.19. What is the difference between the highest and the lowest Net enrolment rate(%) of Least developed countries?
Provide a short and direct response. 29.3. What is the difference between the highest and the lowest Net enrolment rate(%) in Congo (Republic)?
Give a very brief answer. 44.74. What is the difference between the highest and the lowest Net enrolment rate(%) in Japan?
Ensure brevity in your answer.  0.09. What is the difference between the highest and the lowest Net enrolment rate(%) of Venezuela?
Make the answer very short. 12.37. 